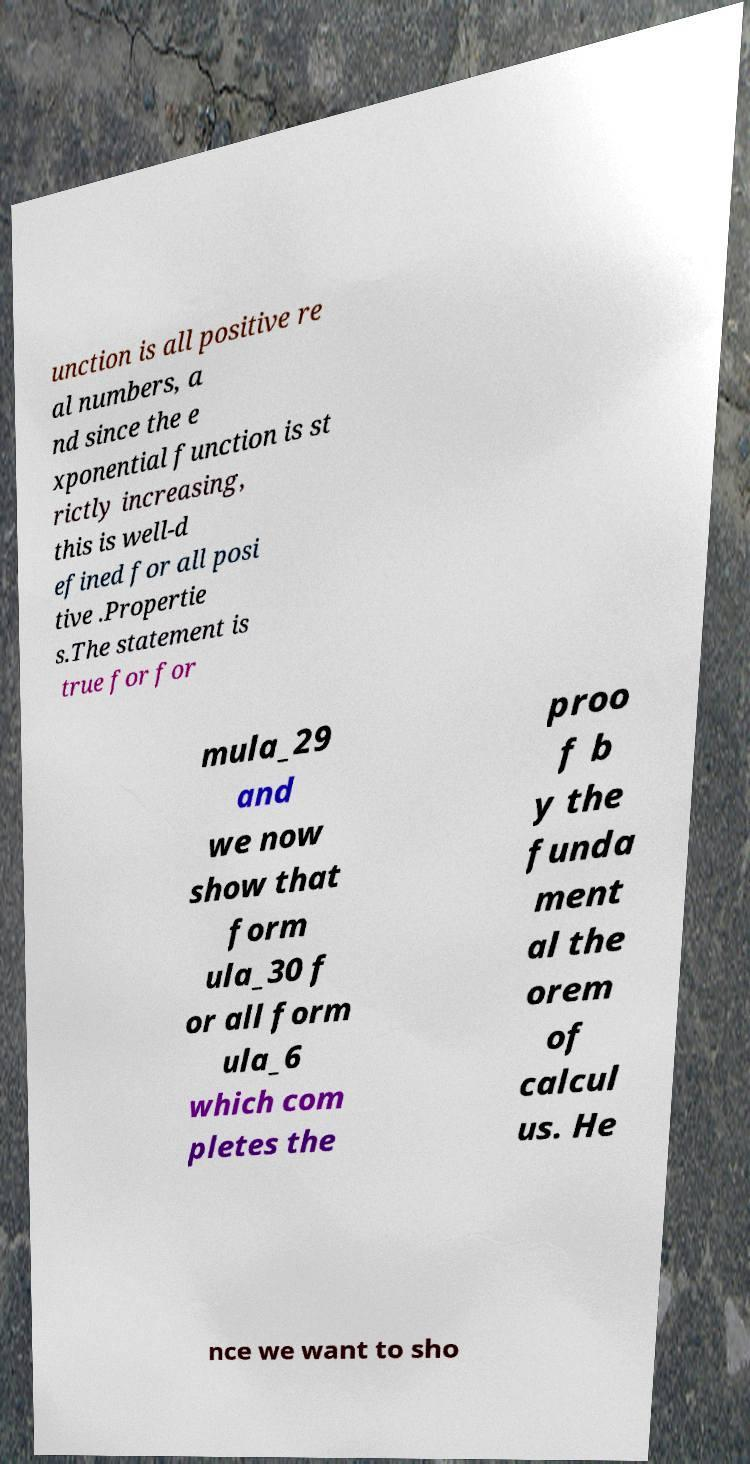Please identify and transcribe the text found in this image. unction is all positive re al numbers, a nd since the e xponential function is st rictly increasing, this is well-d efined for all posi tive .Propertie s.The statement is true for for mula_29 and we now show that form ula_30 f or all form ula_6 which com pletes the proo f b y the funda ment al the orem of calcul us. He nce we want to sho 